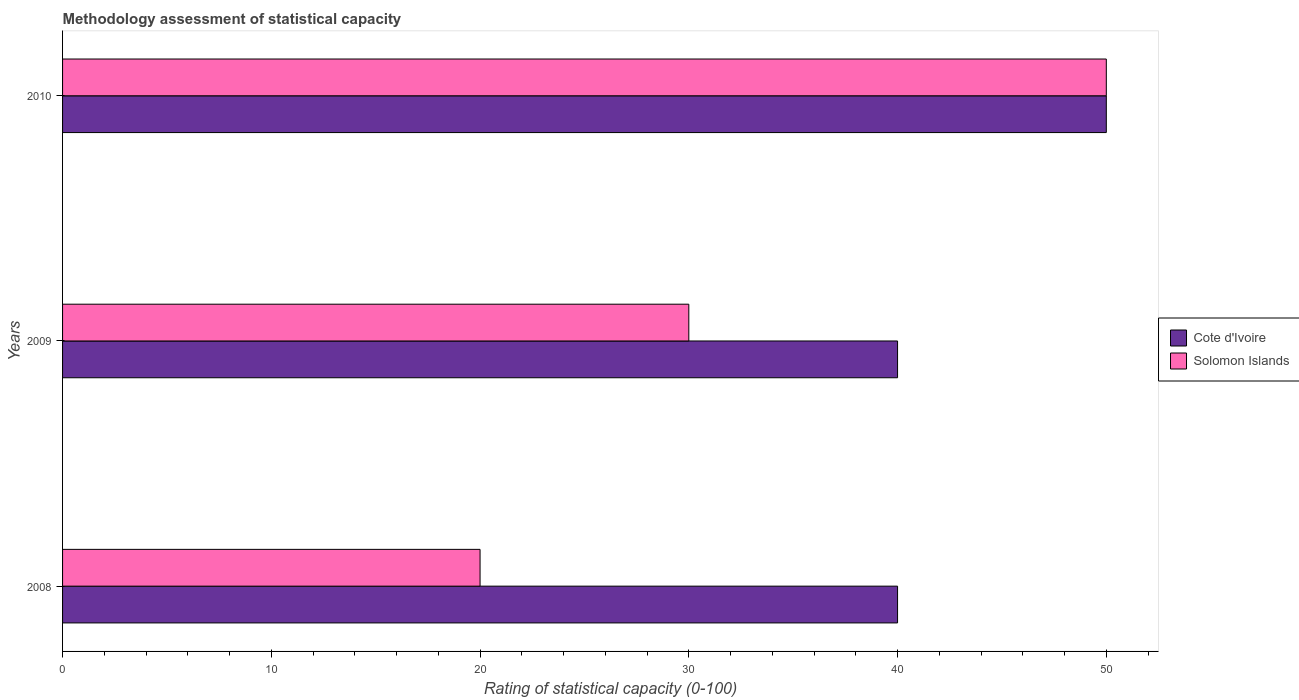How many different coloured bars are there?
Provide a short and direct response. 2. Are the number of bars per tick equal to the number of legend labels?
Your answer should be very brief. Yes. Are the number of bars on each tick of the Y-axis equal?
Provide a short and direct response. Yes. How many bars are there on the 1st tick from the bottom?
Give a very brief answer. 2. In how many cases, is the number of bars for a given year not equal to the number of legend labels?
Make the answer very short. 0. What is the rating of statistical capacity in Solomon Islands in 2009?
Make the answer very short. 30. Across all years, what is the minimum rating of statistical capacity in Cote d'Ivoire?
Your answer should be very brief. 40. In which year was the rating of statistical capacity in Solomon Islands maximum?
Offer a terse response. 2010. What is the difference between the rating of statistical capacity in Cote d'Ivoire in 2009 and that in 2010?
Your answer should be very brief. -10. What is the average rating of statistical capacity in Cote d'Ivoire per year?
Offer a very short reply. 43.33. In the year 2010, what is the difference between the rating of statistical capacity in Cote d'Ivoire and rating of statistical capacity in Solomon Islands?
Your answer should be compact. 0. What is the difference between the highest and the second highest rating of statistical capacity in Cote d'Ivoire?
Ensure brevity in your answer.  10. What is the difference between the highest and the lowest rating of statistical capacity in Solomon Islands?
Offer a terse response. 30. In how many years, is the rating of statistical capacity in Solomon Islands greater than the average rating of statistical capacity in Solomon Islands taken over all years?
Keep it short and to the point. 1. What does the 2nd bar from the top in 2008 represents?
Your response must be concise. Cote d'Ivoire. What does the 2nd bar from the bottom in 2009 represents?
Provide a short and direct response. Solomon Islands. Does the graph contain any zero values?
Give a very brief answer. No. Does the graph contain grids?
Keep it short and to the point. No. What is the title of the graph?
Provide a succinct answer. Methodology assessment of statistical capacity. What is the label or title of the X-axis?
Offer a terse response. Rating of statistical capacity (0-100). What is the Rating of statistical capacity (0-100) of Cote d'Ivoire in 2008?
Keep it short and to the point. 40. What is the Rating of statistical capacity (0-100) in Cote d'Ivoire in 2010?
Your answer should be compact. 50. Across all years, what is the minimum Rating of statistical capacity (0-100) of Cote d'Ivoire?
Offer a very short reply. 40. What is the total Rating of statistical capacity (0-100) of Cote d'Ivoire in the graph?
Make the answer very short. 130. What is the difference between the Rating of statistical capacity (0-100) in Cote d'Ivoire in 2009 and that in 2010?
Make the answer very short. -10. What is the difference between the Rating of statistical capacity (0-100) in Cote d'Ivoire in 2008 and the Rating of statistical capacity (0-100) in Solomon Islands in 2009?
Ensure brevity in your answer.  10. What is the difference between the Rating of statistical capacity (0-100) of Cote d'Ivoire in 2008 and the Rating of statistical capacity (0-100) of Solomon Islands in 2010?
Your response must be concise. -10. What is the difference between the Rating of statistical capacity (0-100) of Cote d'Ivoire in 2009 and the Rating of statistical capacity (0-100) of Solomon Islands in 2010?
Provide a short and direct response. -10. What is the average Rating of statistical capacity (0-100) of Cote d'Ivoire per year?
Provide a succinct answer. 43.33. What is the average Rating of statistical capacity (0-100) of Solomon Islands per year?
Your answer should be very brief. 33.33. In the year 2009, what is the difference between the Rating of statistical capacity (0-100) of Cote d'Ivoire and Rating of statistical capacity (0-100) of Solomon Islands?
Your answer should be compact. 10. What is the ratio of the Rating of statistical capacity (0-100) in Cote d'Ivoire in 2008 to that in 2009?
Your answer should be compact. 1. What is the ratio of the Rating of statistical capacity (0-100) of Solomon Islands in 2008 to that in 2009?
Your answer should be very brief. 0.67. What is the ratio of the Rating of statistical capacity (0-100) in Cote d'Ivoire in 2008 to that in 2010?
Offer a terse response. 0.8. What is the ratio of the Rating of statistical capacity (0-100) in Cote d'Ivoire in 2009 to that in 2010?
Your answer should be very brief. 0.8. What is the difference between the highest and the second highest Rating of statistical capacity (0-100) in Cote d'Ivoire?
Make the answer very short. 10. What is the difference between the highest and the second highest Rating of statistical capacity (0-100) of Solomon Islands?
Make the answer very short. 20. 